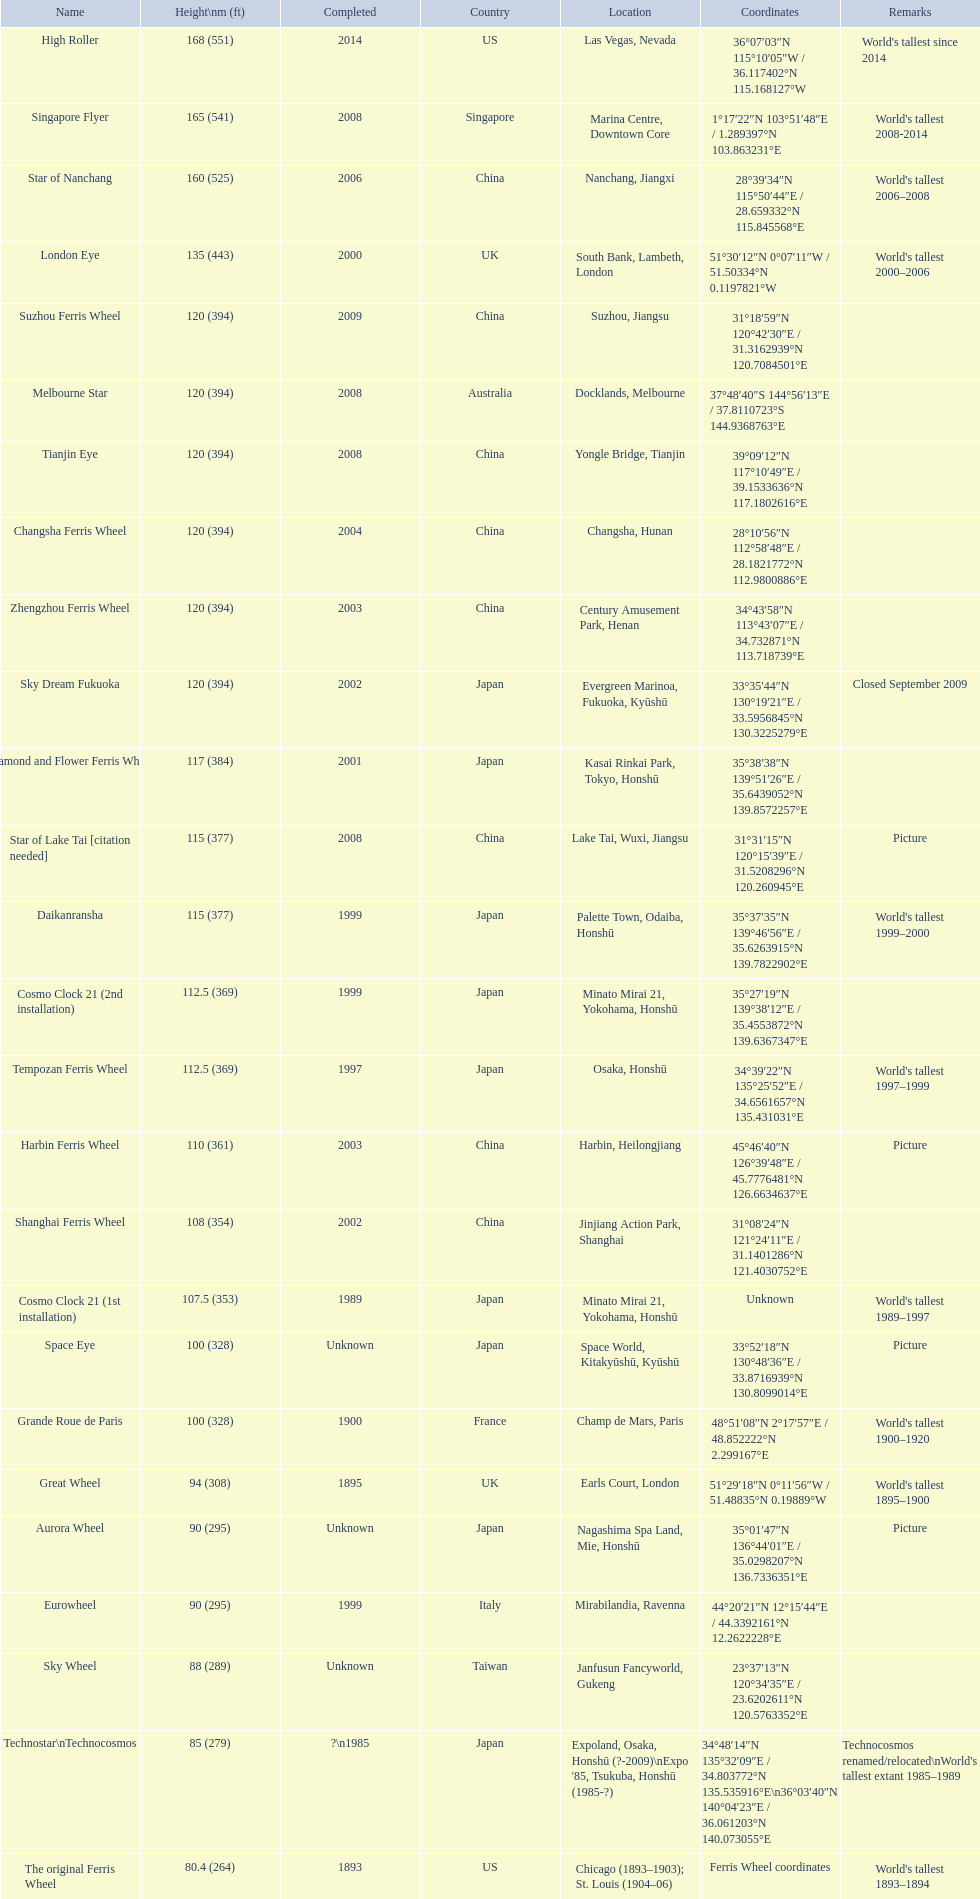When was the high roller ferris wheel finished? 2014. Which ferris wheel reached completion in 2006? Star of Nanchang. Which one was finished in 2008? Singapore Flyer. 